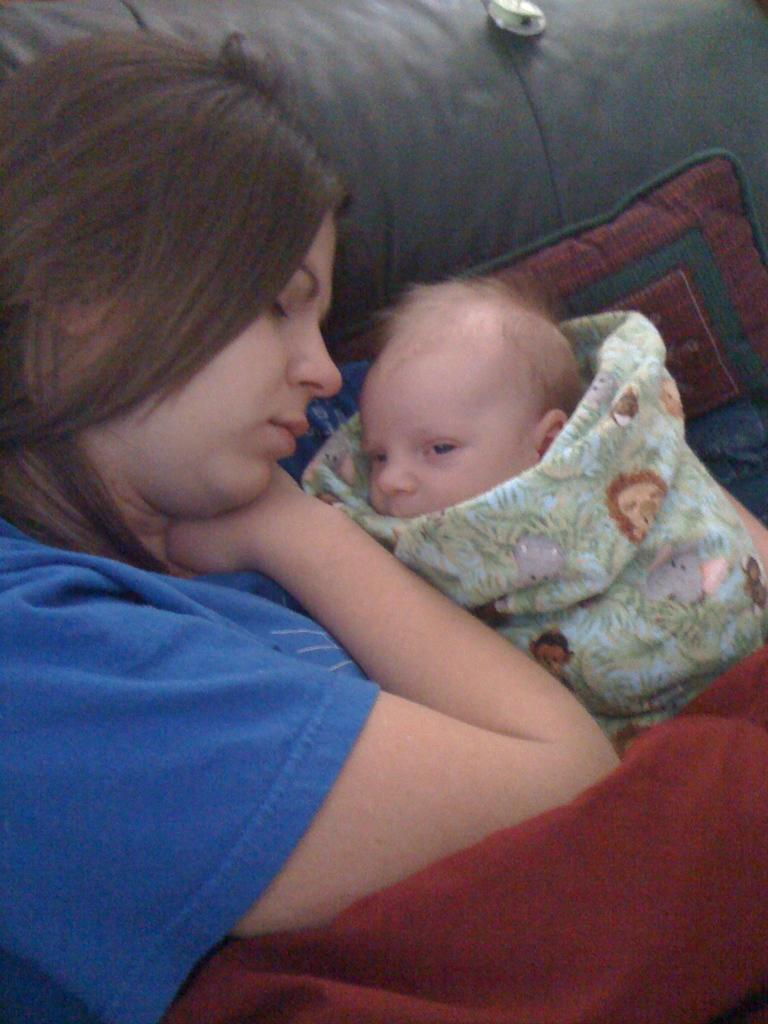Who is present in the image? There is a woman in the image. What is the woman wearing? The woman is wearing a blue dress. Who else can be seen in the image? There is a child in the image. What type of furniture is in the image? There is a sofa in the image. What color is the cloth in the image? There is a red cloth in the image. What type of jeans is the crow wearing in the image? There is no crow or jeans present in the image. 